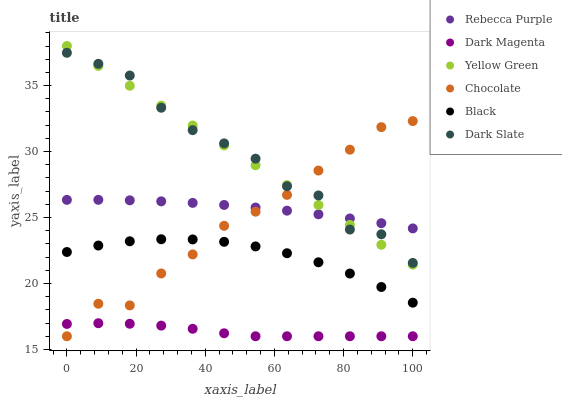Does Dark Magenta have the minimum area under the curve?
Answer yes or no. Yes. Does Dark Slate have the maximum area under the curve?
Answer yes or no. Yes. Does Chocolate have the minimum area under the curve?
Answer yes or no. No. Does Chocolate have the maximum area under the curve?
Answer yes or no. No. Is Yellow Green the smoothest?
Answer yes or no. Yes. Is Dark Slate the roughest?
Answer yes or no. Yes. Is Chocolate the smoothest?
Answer yes or no. No. Is Chocolate the roughest?
Answer yes or no. No. Does Chocolate have the lowest value?
Answer yes or no. Yes. Does Dark Slate have the lowest value?
Answer yes or no. No. Does Yellow Green have the highest value?
Answer yes or no. Yes. Does Chocolate have the highest value?
Answer yes or no. No. Is Black less than Yellow Green?
Answer yes or no. Yes. Is Rebecca Purple greater than Black?
Answer yes or no. Yes. Does Chocolate intersect Yellow Green?
Answer yes or no. Yes. Is Chocolate less than Yellow Green?
Answer yes or no. No. Is Chocolate greater than Yellow Green?
Answer yes or no. No. Does Black intersect Yellow Green?
Answer yes or no. No. 